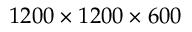<formula> <loc_0><loc_0><loc_500><loc_500>1 2 0 0 \times 1 2 0 0 \times 6 0 0</formula> 